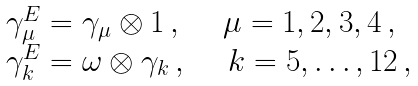<formula> <loc_0><loc_0><loc_500><loc_500>\begin{array} { l } \gamma _ { \mu } ^ { E } = \gamma _ { \mu } \otimes 1 \, , \ \quad \mu = 1 , 2 , 3 , 4 \, , \\ \gamma _ { k } ^ { E } = \omega \otimes \gamma _ { k } \, , \ \quad k = 5 , \dots , 1 2 \, , \\ \end{array}</formula> 